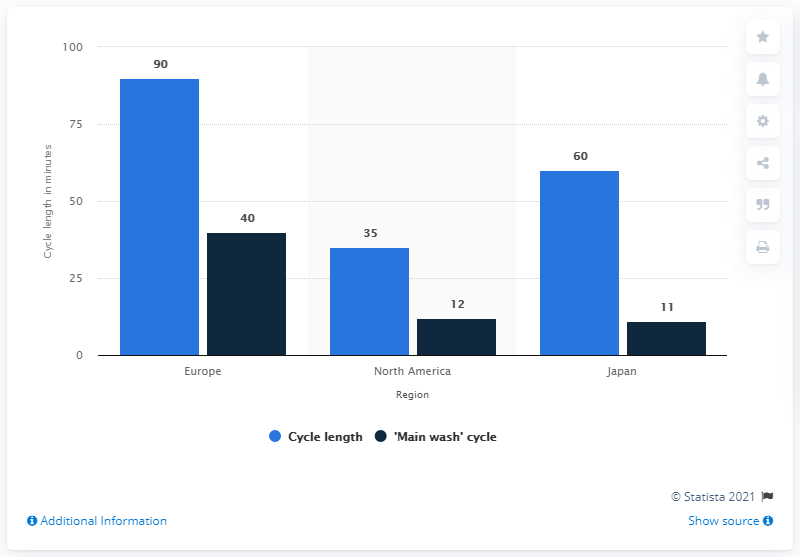Identify some key points in this picture. The country with the greatest difference between two factors is Europe. The chart represents 3 countries. 